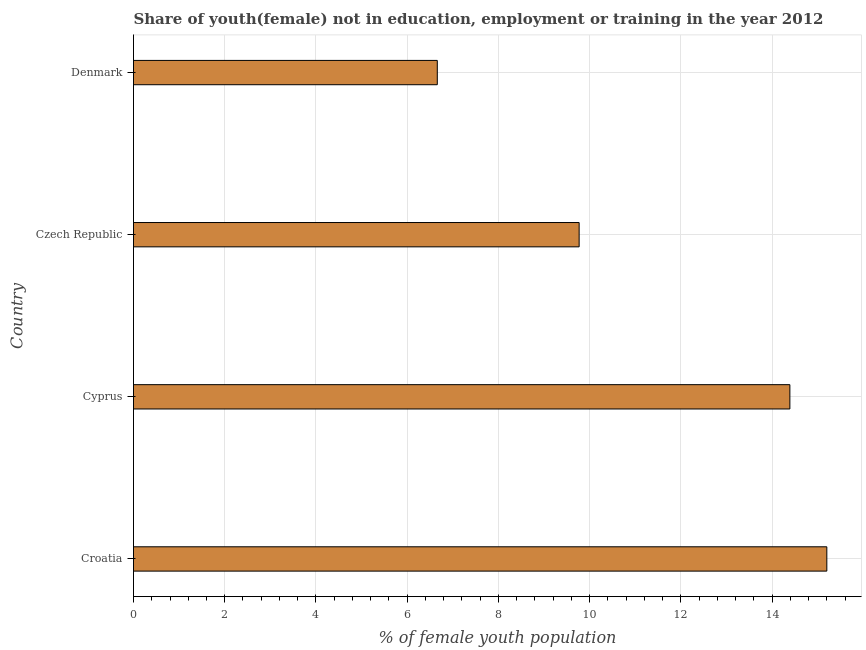What is the title of the graph?
Your response must be concise. Share of youth(female) not in education, employment or training in the year 2012. What is the label or title of the X-axis?
Ensure brevity in your answer.  % of female youth population. What is the unemployed female youth population in Cyprus?
Your response must be concise. 14.39. Across all countries, what is the maximum unemployed female youth population?
Your answer should be very brief. 15.2. Across all countries, what is the minimum unemployed female youth population?
Ensure brevity in your answer.  6.66. In which country was the unemployed female youth population maximum?
Offer a very short reply. Croatia. What is the sum of the unemployed female youth population?
Your answer should be very brief. 46.02. What is the difference between the unemployed female youth population in Cyprus and Czech Republic?
Provide a short and direct response. 4.62. What is the average unemployed female youth population per country?
Ensure brevity in your answer.  11.51. What is the median unemployed female youth population?
Provide a short and direct response. 12.08. In how many countries, is the unemployed female youth population greater than 5.2 %?
Keep it short and to the point. 4. What is the ratio of the unemployed female youth population in Czech Republic to that in Denmark?
Ensure brevity in your answer.  1.47. Is the difference between the unemployed female youth population in Croatia and Cyprus greater than the difference between any two countries?
Your answer should be compact. No. What is the difference between the highest and the second highest unemployed female youth population?
Your answer should be compact. 0.81. Is the sum of the unemployed female youth population in Croatia and Cyprus greater than the maximum unemployed female youth population across all countries?
Make the answer very short. Yes. What is the difference between the highest and the lowest unemployed female youth population?
Offer a very short reply. 8.54. In how many countries, is the unemployed female youth population greater than the average unemployed female youth population taken over all countries?
Your response must be concise. 2. What is the difference between two consecutive major ticks on the X-axis?
Provide a succinct answer. 2. Are the values on the major ticks of X-axis written in scientific E-notation?
Your response must be concise. No. What is the % of female youth population in Croatia?
Offer a very short reply. 15.2. What is the % of female youth population of Cyprus?
Keep it short and to the point. 14.39. What is the % of female youth population in Czech Republic?
Keep it short and to the point. 9.77. What is the % of female youth population of Denmark?
Your answer should be compact. 6.66. What is the difference between the % of female youth population in Croatia and Cyprus?
Your answer should be very brief. 0.81. What is the difference between the % of female youth population in Croatia and Czech Republic?
Your answer should be compact. 5.43. What is the difference between the % of female youth population in Croatia and Denmark?
Your response must be concise. 8.54. What is the difference between the % of female youth population in Cyprus and Czech Republic?
Your answer should be compact. 4.62. What is the difference between the % of female youth population in Cyprus and Denmark?
Provide a succinct answer. 7.73. What is the difference between the % of female youth population in Czech Republic and Denmark?
Ensure brevity in your answer.  3.11. What is the ratio of the % of female youth population in Croatia to that in Cyprus?
Your answer should be very brief. 1.06. What is the ratio of the % of female youth population in Croatia to that in Czech Republic?
Provide a short and direct response. 1.56. What is the ratio of the % of female youth population in Croatia to that in Denmark?
Keep it short and to the point. 2.28. What is the ratio of the % of female youth population in Cyprus to that in Czech Republic?
Your answer should be compact. 1.47. What is the ratio of the % of female youth population in Cyprus to that in Denmark?
Make the answer very short. 2.16. What is the ratio of the % of female youth population in Czech Republic to that in Denmark?
Provide a succinct answer. 1.47. 